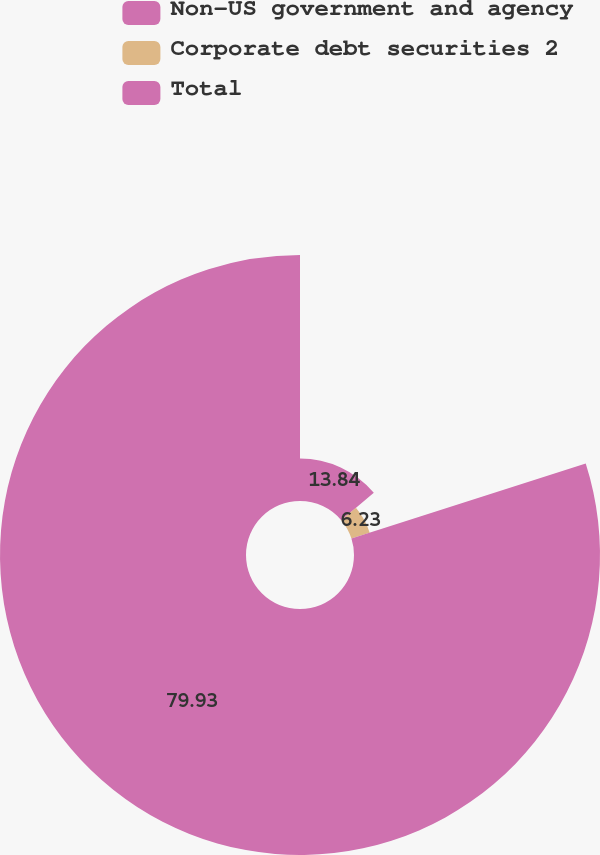<chart> <loc_0><loc_0><loc_500><loc_500><pie_chart><fcel>Non-US government and agency<fcel>Corporate debt securities 2<fcel>Total<nl><fcel>13.84%<fcel>6.23%<fcel>79.93%<nl></chart> 